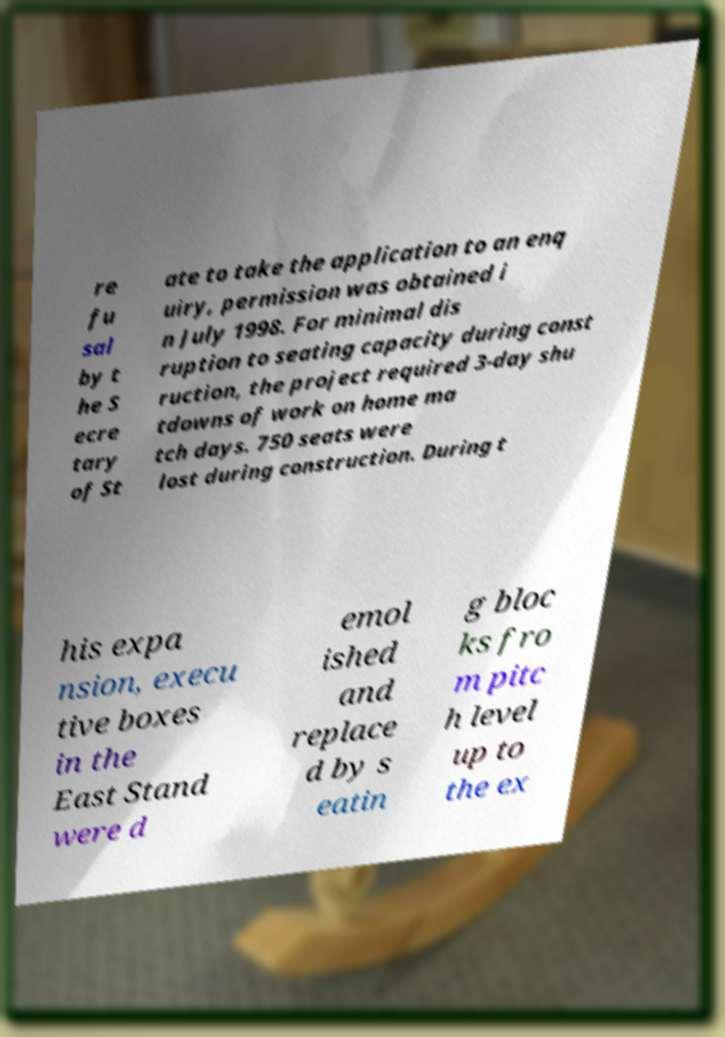Could you extract and type out the text from this image? re fu sal by t he S ecre tary of St ate to take the application to an enq uiry, permission was obtained i n July 1998. For minimal dis ruption to seating capacity during const ruction, the project required 3-day shu tdowns of work on home ma tch days. 750 seats were lost during construction. During t his expa nsion, execu tive boxes in the East Stand were d emol ished and replace d by s eatin g bloc ks fro m pitc h level up to the ex 